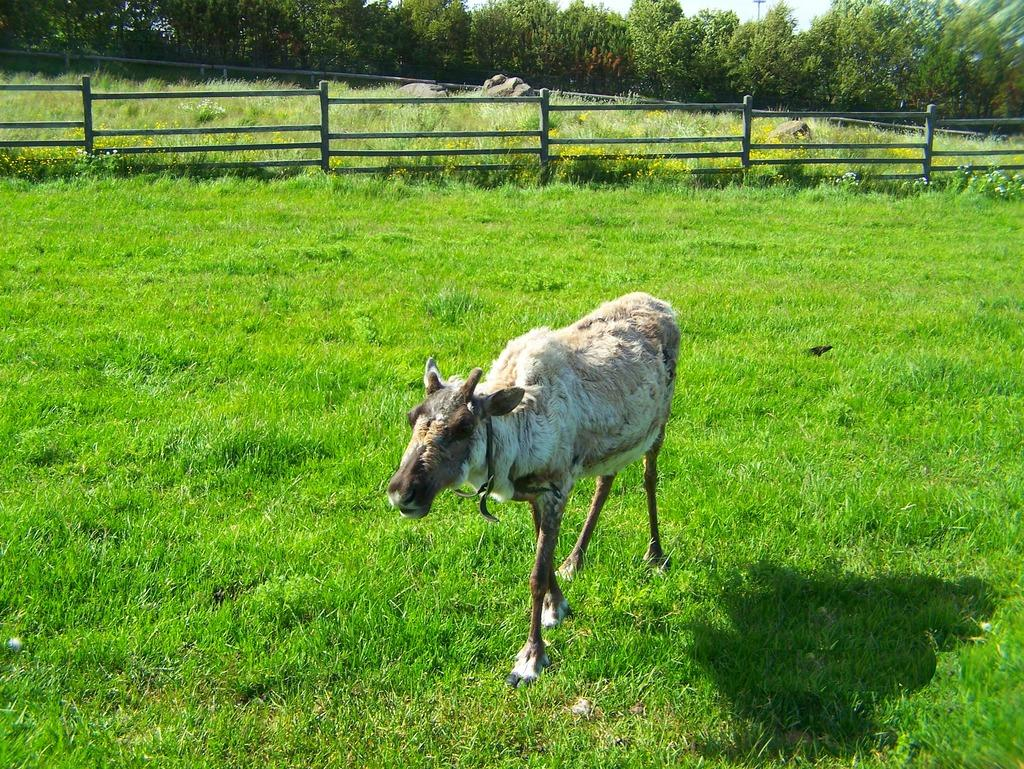What is the main subject in the center of the image? There is a cow in the center of the image. What type of vegetation is visible at the bottom of the image? There is grass at the bottom of the image. What can be seen in the background of the image? There is a fence, grass, and trees in the background of the image. What type of list is the cow holding in the image? There is no list present in the image; the cow is not holding anything. 